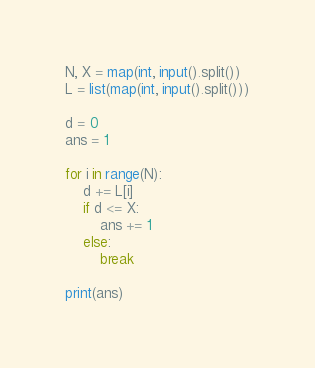<code> <loc_0><loc_0><loc_500><loc_500><_Python_>N, X = map(int, input().split())
L = list(map(int, input().split()))

d = 0
ans = 1

for i in range(N):
    d += L[i]
    if d <= X:
        ans += 1
    else:
        break

print(ans)
</code> 